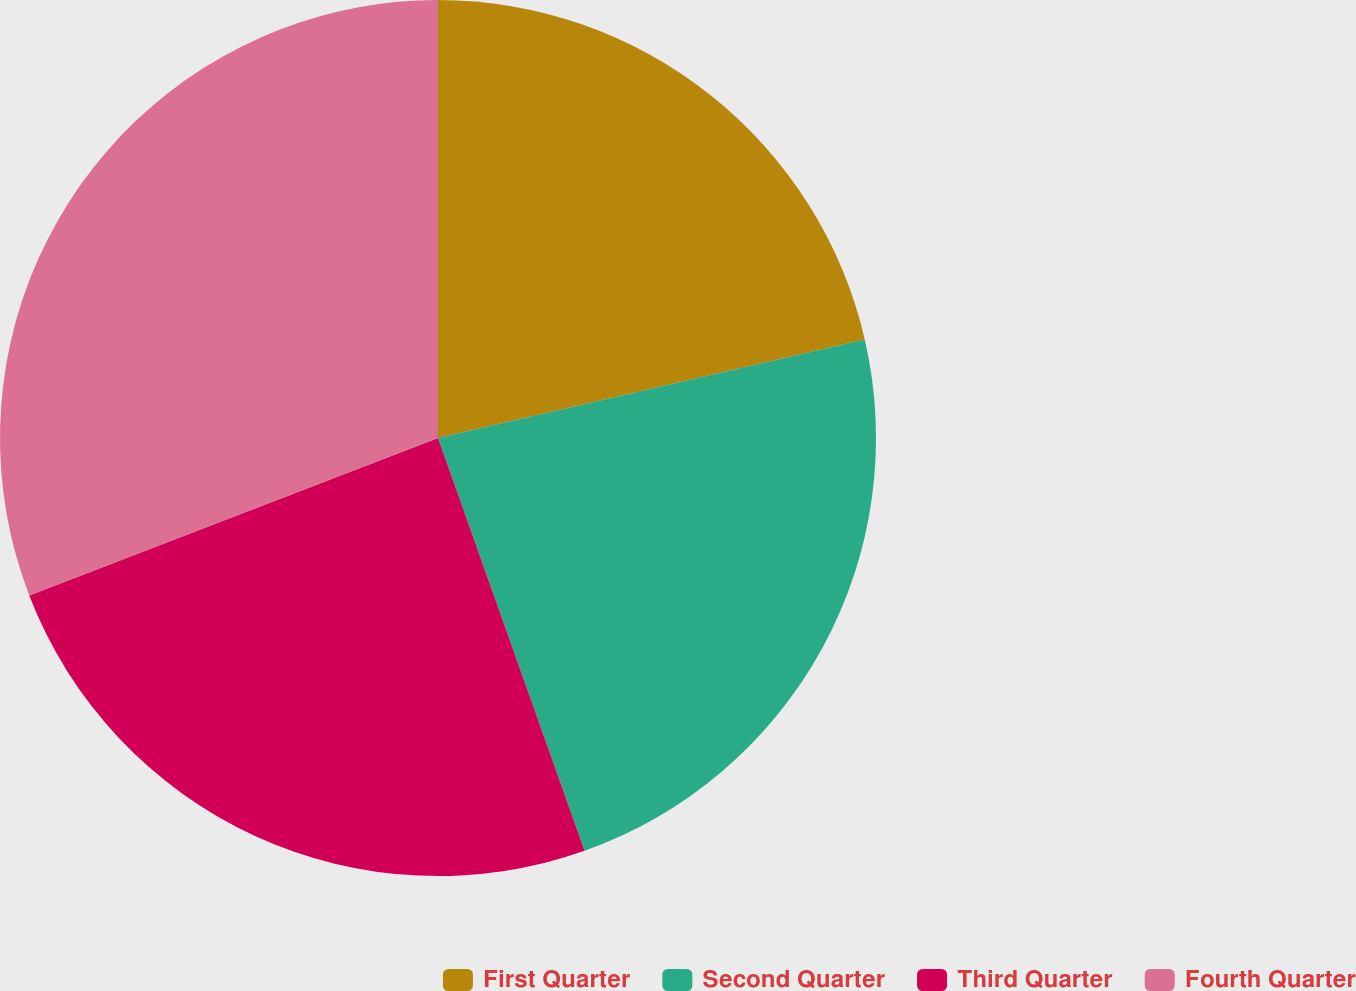<chart> <loc_0><loc_0><loc_500><loc_500><pie_chart><fcel>First Quarter<fcel>Second Quarter<fcel>Third Quarter<fcel>Fourth Quarter<nl><fcel>21.39%<fcel>23.18%<fcel>24.58%<fcel>30.85%<nl></chart> 